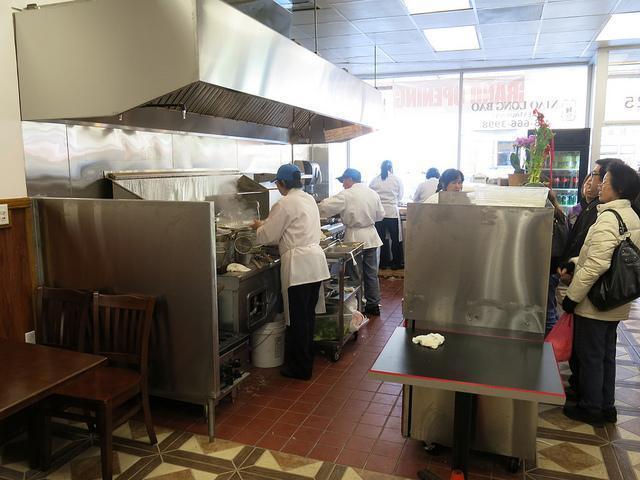How many people are there?
Give a very brief answer. 4. How many dining tables are there?
Give a very brief answer. 2. How many chairs can you see?
Give a very brief answer. 2. How many train cars are in the picture?
Give a very brief answer. 0. 